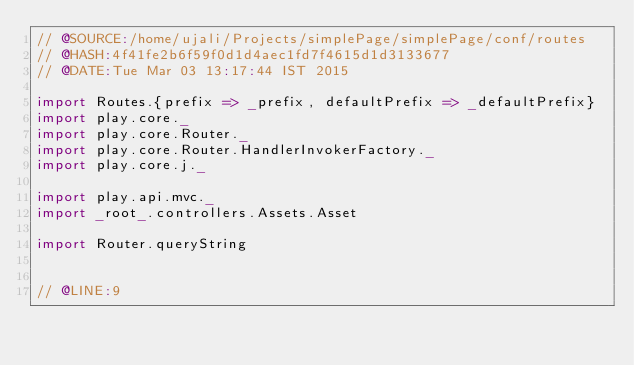Convert code to text. <code><loc_0><loc_0><loc_500><loc_500><_Scala_>// @SOURCE:/home/ujali/Projects/simplePage/simplePage/conf/routes
// @HASH:4f41fe2b6f59f0d1d4aec1fd7f4615d1d3133677
// @DATE:Tue Mar 03 13:17:44 IST 2015

import Routes.{prefix => _prefix, defaultPrefix => _defaultPrefix}
import play.core._
import play.core.Router._
import play.core.Router.HandlerInvokerFactory._
import play.core.j._

import play.api.mvc._
import _root_.controllers.Assets.Asset

import Router.queryString


// @LINE:9</code> 